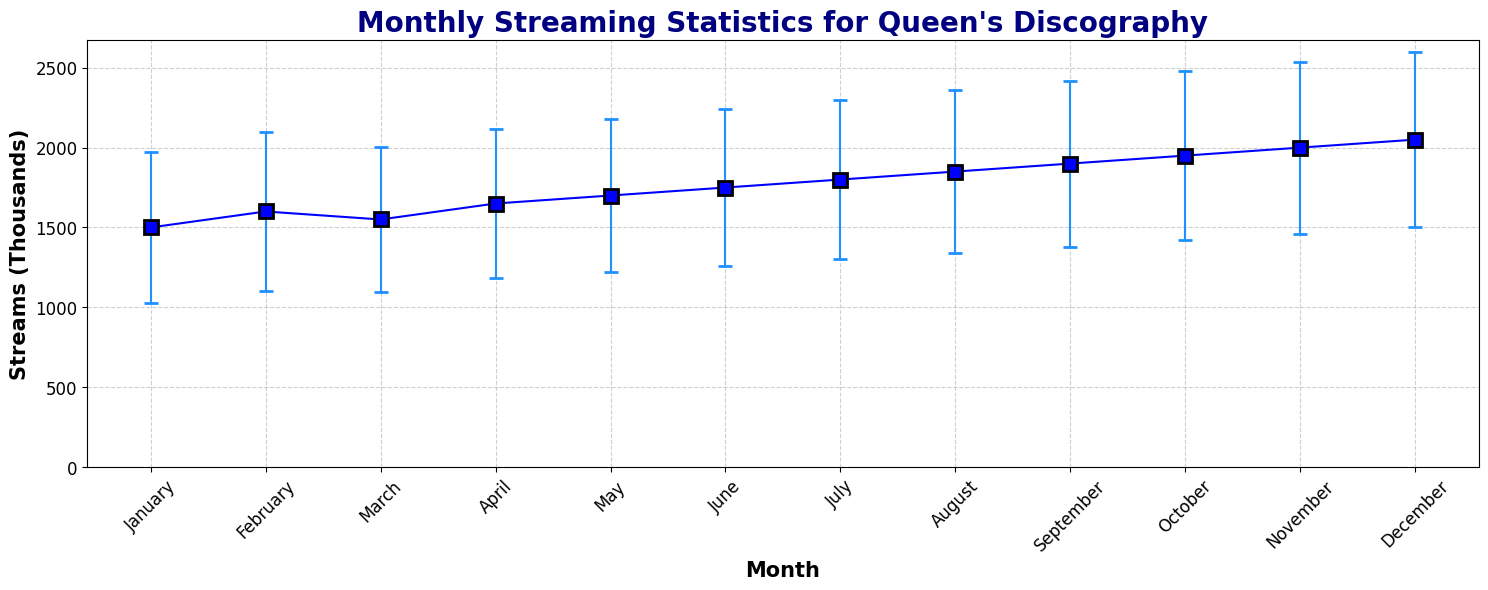Which month has the highest number of streams? By visually inspecting the chart, the data point for December is the highest on the y-axis.
Answer: December Which month has the lowest number of streams? By looking at the chart, January is the lowest on the y-axis among all the months.
Answer: January What is the difference in the number of streams between December and January? The number of streams for December is 2050k and for January is 1500k. The difference is 2050 - 1500.
Answer: 550k During which months do the streams fluctuate the most based on standard deviation? Observing the error bars, December has the largest error bar which represents the highest standard deviation.
Answer: December What is the average number of streams from January to March? The streams for January, February, and March are 1500k, 1600k, and 1550k. Average = (1500 + 1600 + 1550) / 3.
Answer: 1550k Is the trend from June to December generally increasing or decreasing? By visually inspecting, the trend from June to December generally shows an increasing pattern in the data points.
Answer: Increasing How does the variability of streams in October compare to April? Comparing the error bars for October and April visually, October has a larger error bar than April, indicating higher variability.
Answer: October has higher variability What is the sum of streams from July and August? The streams for July and August are 1800k and 1850k. The sum is 1800 + 1850.
Answer: 3650k Which month has less variability, February or March, based on the standard deviation? Comparing the standard deviations, February has 494.97 and March has 452.77. March has a lower standard deviation, indicating less variability.
Answer: March Which months have more than 1800k streams? Observing the data points visually, the months with more than 1800k streams are August, September, October, November, and December.
Answer: August, September, October, November, December 